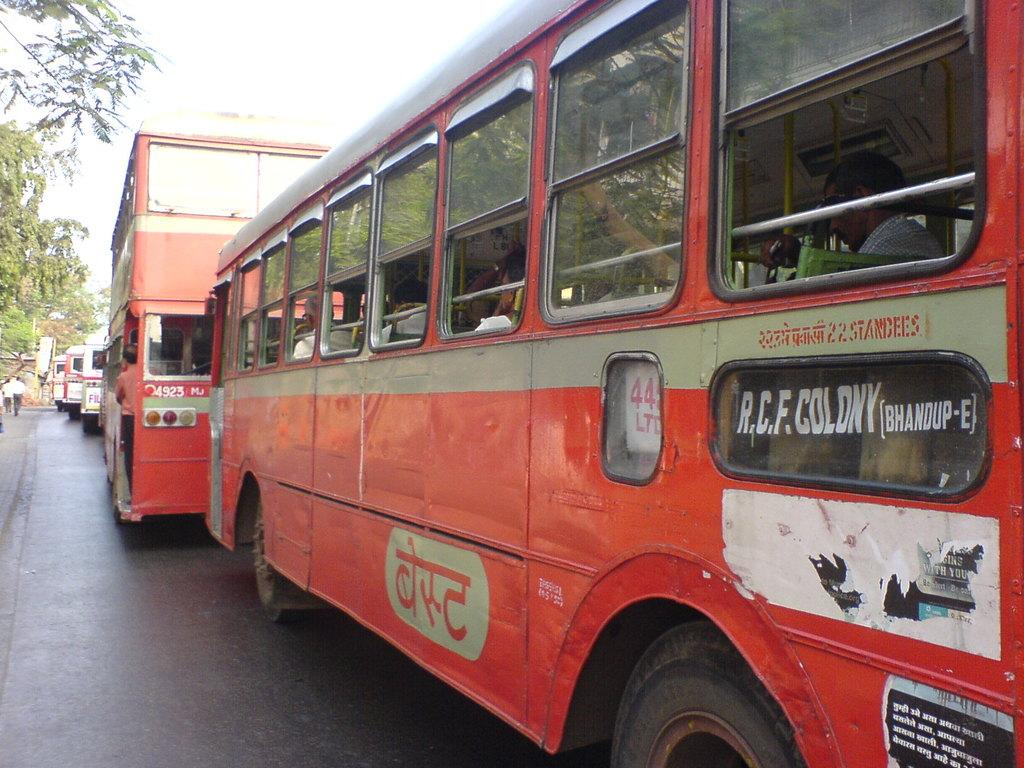What type of vehicles are in the center of the image? There are red color buses in the center of the image. Where are the buses located? The buses are on the road. What is visible at the top of the image? There is sky visible at the top of the image. What type of vegetation is on the left side of the image? There are trees to the left side of the image. Can you tell me how many people are smiling on the buses in the image? There is no information about people smiling on the buses in the image, as the facts provided only mention the color and location of the buses. 